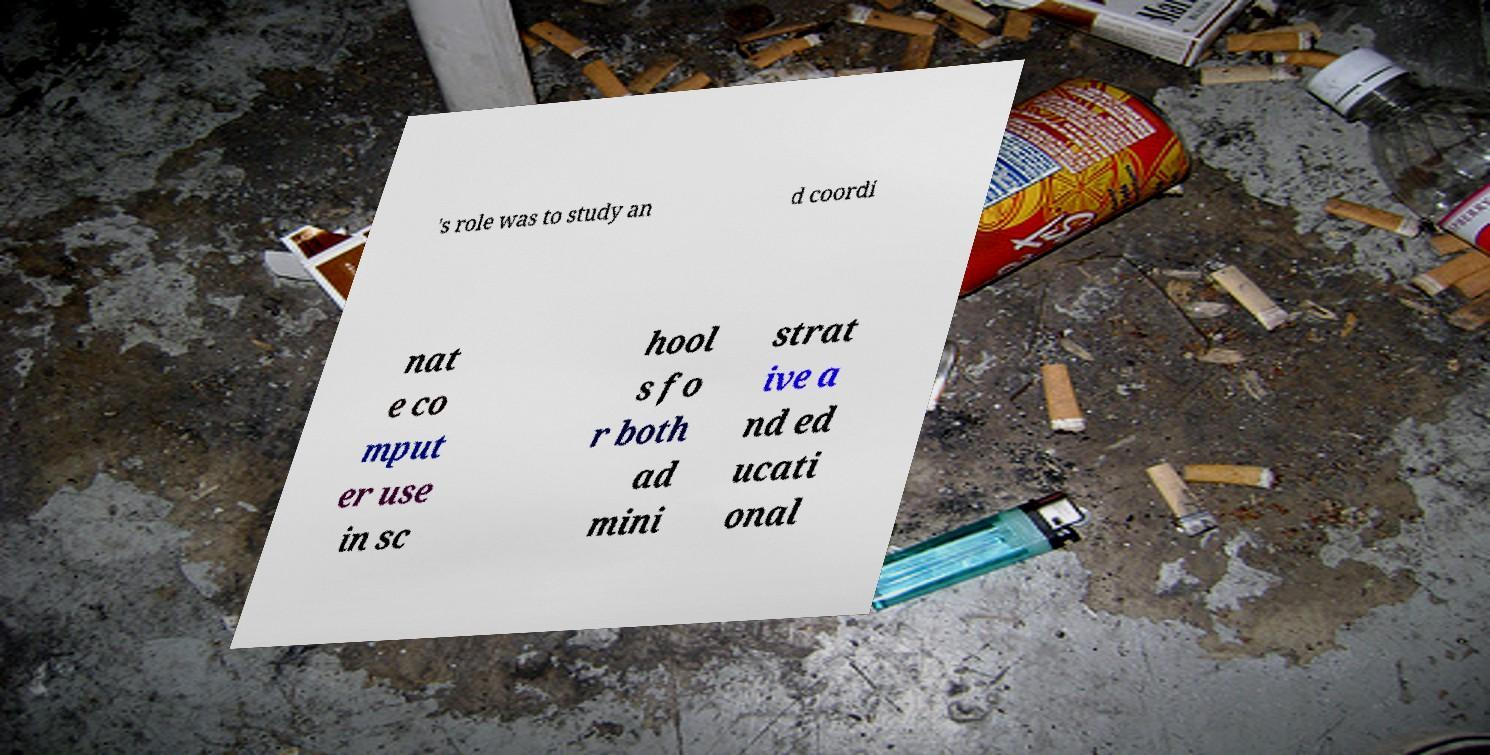Could you extract and type out the text from this image? 's role was to study an d coordi nat e co mput er use in sc hool s fo r both ad mini strat ive a nd ed ucati onal 